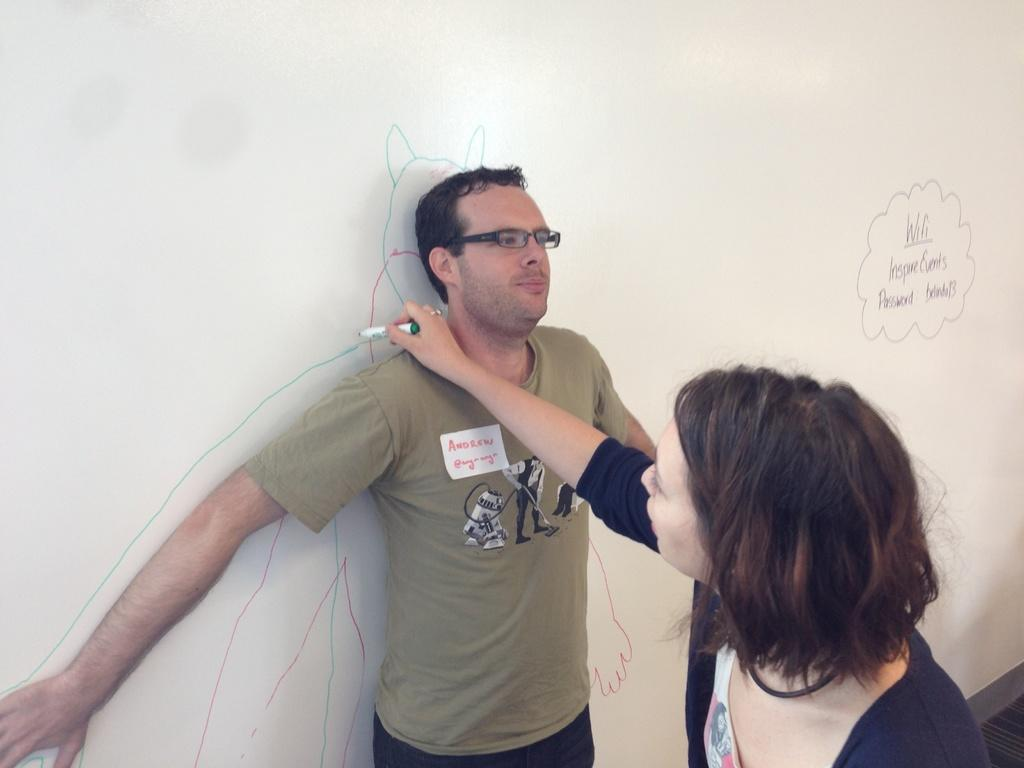What is the main subject of the image? There is a person standing at the board in the center of the image. What is the woman on the right side of the image doing? The woman is writing on the board. Can you describe the board in the background of the image? There is a board in the background of the image. What is the view like from the person's brain in the image? There is no indication of the person's brain in the image, so it is not possible to determine the view from it. 